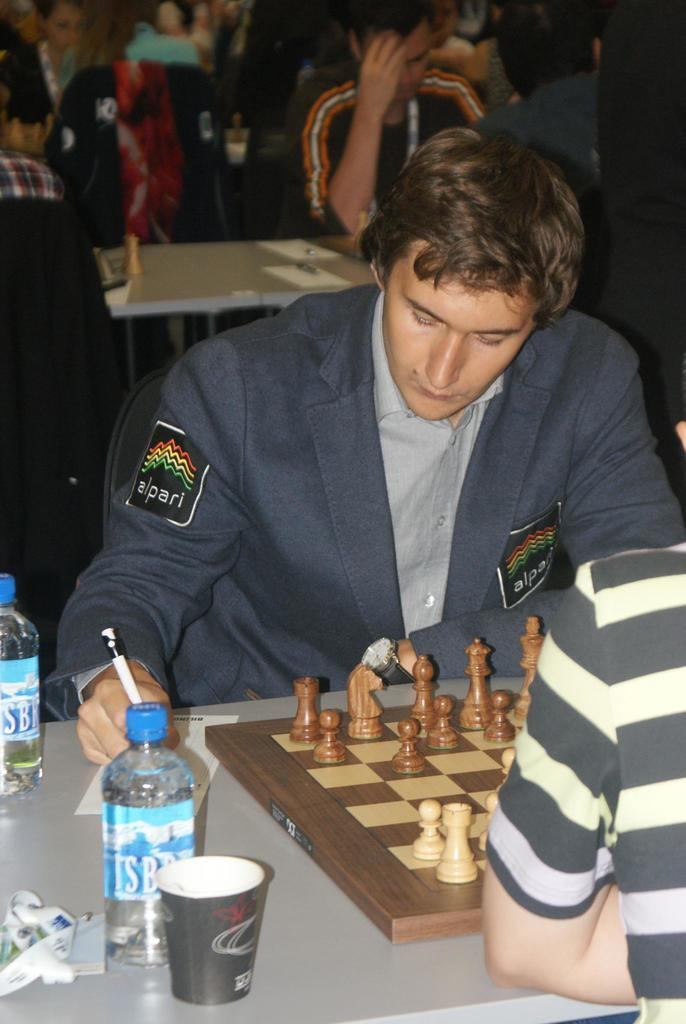What are the people in the image doing? The people in the image are sitting. What is on the table in the image? There is a chess board and bottles on the table. What else is on the table besides the chess board and bottles? There is a glass on the table. What country is depicted on the foot of the person sitting in the image? There is no mention of a foot or a country in the image, so this question cannot be answered. 